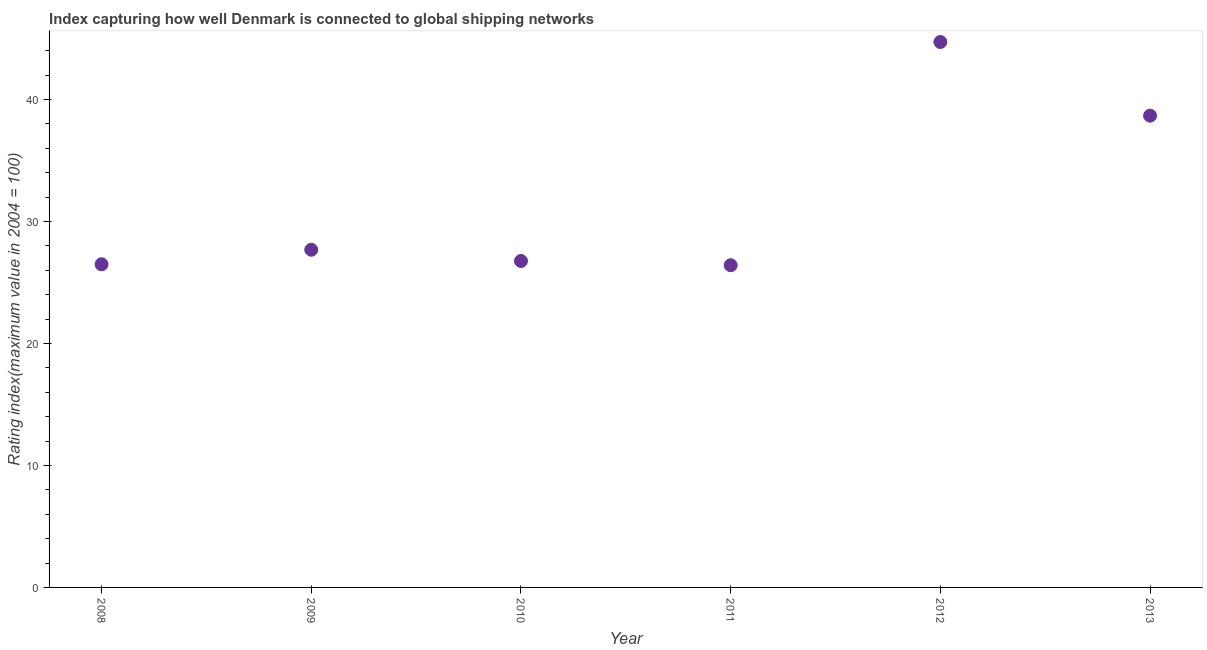What is the liner shipping connectivity index in 2013?
Provide a succinct answer. 38.67. Across all years, what is the maximum liner shipping connectivity index?
Provide a succinct answer. 44.71. Across all years, what is the minimum liner shipping connectivity index?
Provide a succinct answer. 26.41. In which year was the liner shipping connectivity index maximum?
Make the answer very short. 2012. In which year was the liner shipping connectivity index minimum?
Your answer should be very brief. 2011. What is the sum of the liner shipping connectivity index?
Your answer should be very brief. 190.72. What is the difference between the liner shipping connectivity index in 2008 and 2012?
Your answer should be compact. -18.22. What is the average liner shipping connectivity index per year?
Provide a succinct answer. 31.79. What is the median liner shipping connectivity index?
Provide a short and direct response. 27.22. What is the ratio of the liner shipping connectivity index in 2010 to that in 2013?
Keep it short and to the point. 0.69. Is the liner shipping connectivity index in 2009 less than that in 2011?
Your answer should be very brief. No. What is the difference between the highest and the second highest liner shipping connectivity index?
Your answer should be compact. 6.04. Is the sum of the liner shipping connectivity index in 2008 and 2011 greater than the maximum liner shipping connectivity index across all years?
Offer a very short reply. Yes. Does the liner shipping connectivity index monotonically increase over the years?
Your answer should be compact. No. How many dotlines are there?
Your answer should be very brief. 1. How many years are there in the graph?
Your answer should be compact. 6. What is the difference between two consecutive major ticks on the Y-axis?
Keep it short and to the point. 10. Does the graph contain grids?
Keep it short and to the point. No. What is the title of the graph?
Offer a very short reply. Index capturing how well Denmark is connected to global shipping networks. What is the label or title of the X-axis?
Offer a very short reply. Year. What is the label or title of the Y-axis?
Make the answer very short. Rating index(maximum value in 2004 = 100). What is the Rating index(maximum value in 2004 = 100) in 2008?
Your answer should be very brief. 26.49. What is the Rating index(maximum value in 2004 = 100) in 2009?
Your answer should be compact. 27.68. What is the Rating index(maximum value in 2004 = 100) in 2010?
Ensure brevity in your answer.  26.76. What is the Rating index(maximum value in 2004 = 100) in 2011?
Ensure brevity in your answer.  26.41. What is the Rating index(maximum value in 2004 = 100) in 2012?
Make the answer very short. 44.71. What is the Rating index(maximum value in 2004 = 100) in 2013?
Your response must be concise. 38.67. What is the difference between the Rating index(maximum value in 2004 = 100) in 2008 and 2009?
Offer a terse response. -1.19. What is the difference between the Rating index(maximum value in 2004 = 100) in 2008 and 2010?
Provide a succinct answer. -0.27. What is the difference between the Rating index(maximum value in 2004 = 100) in 2008 and 2011?
Your answer should be compact. 0.08. What is the difference between the Rating index(maximum value in 2004 = 100) in 2008 and 2012?
Give a very brief answer. -18.22. What is the difference between the Rating index(maximum value in 2004 = 100) in 2008 and 2013?
Make the answer very short. -12.18. What is the difference between the Rating index(maximum value in 2004 = 100) in 2009 and 2010?
Make the answer very short. 0.92. What is the difference between the Rating index(maximum value in 2004 = 100) in 2009 and 2011?
Make the answer very short. 1.27. What is the difference between the Rating index(maximum value in 2004 = 100) in 2009 and 2012?
Your answer should be very brief. -17.03. What is the difference between the Rating index(maximum value in 2004 = 100) in 2009 and 2013?
Provide a short and direct response. -10.99. What is the difference between the Rating index(maximum value in 2004 = 100) in 2010 and 2012?
Your answer should be compact. -17.95. What is the difference between the Rating index(maximum value in 2004 = 100) in 2010 and 2013?
Provide a short and direct response. -11.91. What is the difference between the Rating index(maximum value in 2004 = 100) in 2011 and 2012?
Ensure brevity in your answer.  -18.3. What is the difference between the Rating index(maximum value in 2004 = 100) in 2011 and 2013?
Your answer should be compact. -12.26. What is the difference between the Rating index(maximum value in 2004 = 100) in 2012 and 2013?
Offer a very short reply. 6.04. What is the ratio of the Rating index(maximum value in 2004 = 100) in 2008 to that in 2010?
Ensure brevity in your answer.  0.99. What is the ratio of the Rating index(maximum value in 2004 = 100) in 2008 to that in 2011?
Give a very brief answer. 1. What is the ratio of the Rating index(maximum value in 2004 = 100) in 2008 to that in 2012?
Provide a succinct answer. 0.59. What is the ratio of the Rating index(maximum value in 2004 = 100) in 2008 to that in 2013?
Provide a short and direct response. 0.69. What is the ratio of the Rating index(maximum value in 2004 = 100) in 2009 to that in 2010?
Offer a terse response. 1.03. What is the ratio of the Rating index(maximum value in 2004 = 100) in 2009 to that in 2011?
Provide a short and direct response. 1.05. What is the ratio of the Rating index(maximum value in 2004 = 100) in 2009 to that in 2012?
Keep it short and to the point. 0.62. What is the ratio of the Rating index(maximum value in 2004 = 100) in 2009 to that in 2013?
Give a very brief answer. 0.72. What is the ratio of the Rating index(maximum value in 2004 = 100) in 2010 to that in 2012?
Your answer should be compact. 0.6. What is the ratio of the Rating index(maximum value in 2004 = 100) in 2010 to that in 2013?
Your answer should be very brief. 0.69. What is the ratio of the Rating index(maximum value in 2004 = 100) in 2011 to that in 2012?
Offer a terse response. 0.59. What is the ratio of the Rating index(maximum value in 2004 = 100) in 2011 to that in 2013?
Ensure brevity in your answer.  0.68. What is the ratio of the Rating index(maximum value in 2004 = 100) in 2012 to that in 2013?
Your answer should be compact. 1.16. 